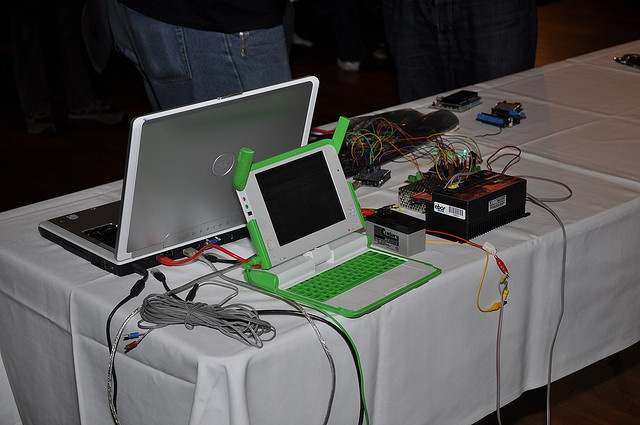Describe the objects in this image and their specific colors. I can see laptop in black, gray, darkgray, and lightgray tones, laptop in black, darkgray, darkgreen, and green tones, people in black and gray tones, people in black tones, and keyboard in black, darkgray, darkgreen, and green tones in this image. 